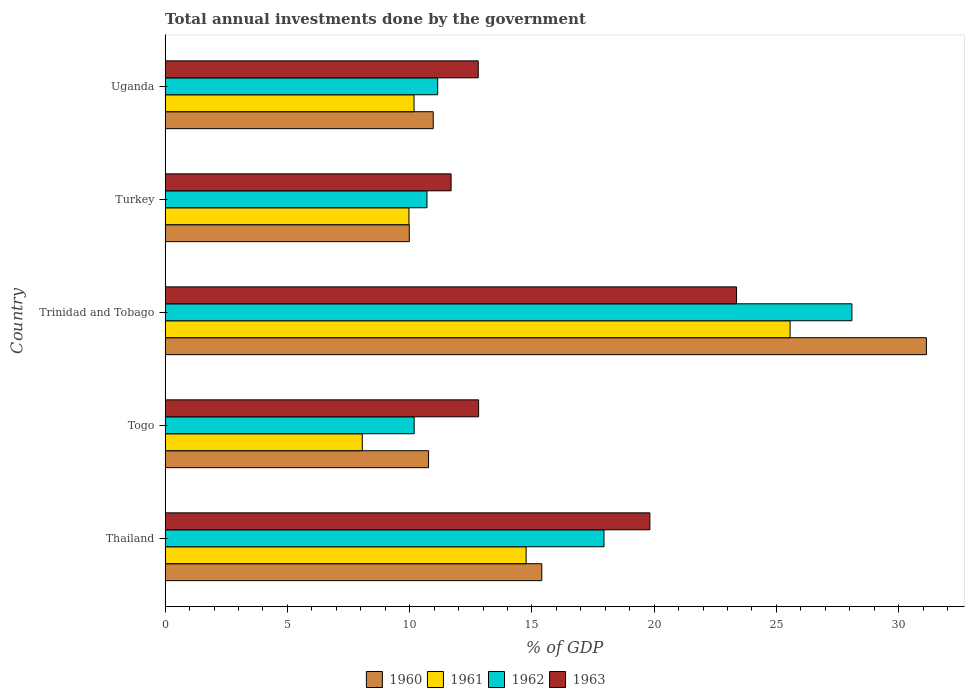How many different coloured bars are there?
Offer a terse response. 4. How many bars are there on the 2nd tick from the top?
Offer a terse response. 4. What is the label of the 2nd group of bars from the top?
Provide a short and direct response. Turkey. What is the total annual investments done by the government in 1962 in Togo?
Make the answer very short. 10.19. Across all countries, what is the maximum total annual investments done by the government in 1961?
Keep it short and to the point. 25.56. Across all countries, what is the minimum total annual investments done by the government in 1963?
Keep it short and to the point. 11.7. In which country was the total annual investments done by the government in 1960 maximum?
Your answer should be very brief. Trinidad and Tobago. In which country was the total annual investments done by the government in 1962 minimum?
Offer a very short reply. Togo. What is the total total annual investments done by the government in 1960 in the graph?
Your answer should be very brief. 78.26. What is the difference between the total annual investments done by the government in 1963 in Togo and that in Turkey?
Your answer should be compact. 1.13. What is the difference between the total annual investments done by the government in 1961 in Togo and the total annual investments done by the government in 1962 in Thailand?
Give a very brief answer. -9.88. What is the average total annual investments done by the government in 1963 per country?
Keep it short and to the point. 16.1. What is the difference between the total annual investments done by the government in 1962 and total annual investments done by the government in 1961 in Uganda?
Keep it short and to the point. 0.97. What is the ratio of the total annual investments done by the government in 1960 in Togo to that in Turkey?
Your answer should be very brief. 1.08. What is the difference between the highest and the second highest total annual investments done by the government in 1963?
Your answer should be very brief. 3.54. What is the difference between the highest and the lowest total annual investments done by the government in 1961?
Make the answer very short. 17.49. In how many countries, is the total annual investments done by the government in 1963 greater than the average total annual investments done by the government in 1963 taken over all countries?
Your response must be concise. 2. Is the sum of the total annual investments done by the government in 1963 in Thailand and Togo greater than the maximum total annual investments done by the government in 1961 across all countries?
Provide a succinct answer. Yes. Is it the case that in every country, the sum of the total annual investments done by the government in 1960 and total annual investments done by the government in 1961 is greater than the sum of total annual investments done by the government in 1963 and total annual investments done by the government in 1962?
Offer a very short reply. No. What does the 3rd bar from the top in Togo represents?
Make the answer very short. 1961. Is it the case that in every country, the sum of the total annual investments done by the government in 1961 and total annual investments done by the government in 1963 is greater than the total annual investments done by the government in 1960?
Give a very brief answer. Yes. How many bars are there?
Make the answer very short. 20. Are all the bars in the graph horizontal?
Offer a terse response. Yes. Does the graph contain any zero values?
Ensure brevity in your answer.  No. How many legend labels are there?
Offer a very short reply. 4. How are the legend labels stacked?
Your answer should be compact. Horizontal. What is the title of the graph?
Your answer should be very brief. Total annual investments done by the government. What is the label or title of the X-axis?
Give a very brief answer. % of GDP. What is the label or title of the Y-axis?
Your response must be concise. Country. What is the % of GDP in 1960 in Thailand?
Give a very brief answer. 15.41. What is the % of GDP of 1961 in Thailand?
Ensure brevity in your answer.  14.76. What is the % of GDP in 1962 in Thailand?
Your response must be concise. 17.95. What is the % of GDP in 1963 in Thailand?
Provide a short and direct response. 19.82. What is the % of GDP in 1960 in Togo?
Your answer should be compact. 10.77. What is the % of GDP in 1961 in Togo?
Offer a very short reply. 8.06. What is the % of GDP of 1962 in Togo?
Your answer should be very brief. 10.19. What is the % of GDP in 1963 in Togo?
Make the answer very short. 12.82. What is the % of GDP of 1960 in Trinidad and Tobago?
Keep it short and to the point. 31.13. What is the % of GDP of 1961 in Trinidad and Tobago?
Give a very brief answer. 25.56. What is the % of GDP in 1962 in Trinidad and Tobago?
Provide a succinct answer. 28.09. What is the % of GDP in 1963 in Trinidad and Tobago?
Offer a terse response. 23.37. What is the % of GDP of 1960 in Turkey?
Your answer should be compact. 9.99. What is the % of GDP in 1961 in Turkey?
Keep it short and to the point. 9.97. What is the % of GDP of 1962 in Turkey?
Provide a short and direct response. 10.71. What is the % of GDP in 1963 in Turkey?
Provide a succinct answer. 11.7. What is the % of GDP in 1960 in Uganda?
Give a very brief answer. 10.96. What is the % of GDP of 1961 in Uganda?
Your answer should be compact. 10.18. What is the % of GDP of 1962 in Uganda?
Provide a short and direct response. 11.15. What is the % of GDP of 1963 in Uganda?
Offer a very short reply. 12.81. Across all countries, what is the maximum % of GDP of 1960?
Provide a succinct answer. 31.13. Across all countries, what is the maximum % of GDP of 1961?
Provide a succinct answer. 25.56. Across all countries, what is the maximum % of GDP in 1962?
Provide a short and direct response. 28.09. Across all countries, what is the maximum % of GDP in 1963?
Provide a succinct answer. 23.37. Across all countries, what is the minimum % of GDP in 1960?
Ensure brevity in your answer.  9.99. Across all countries, what is the minimum % of GDP in 1961?
Offer a very short reply. 8.06. Across all countries, what is the minimum % of GDP in 1962?
Give a very brief answer. 10.19. Across all countries, what is the minimum % of GDP in 1963?
Offer a terse response. 11.7. What is the total % of GDP in 1960 in the graph?
Make the answer very short. 78.26. What is the total % of GDP in 1961 in the graph?
Keep it short and to the point. 68.54. What is the total % of GDP of 1962 in the graph?
Your answer should be very brief. 78.08. What is the total % of GDP in 1963 in the graph?
Give a very brief answer. 80.51. What is the difference between the % of GDP in 1960 in Thailand and that in Togo?
Make the answer very short. 4.63. What is the difference between the % of GDP of 1961 in Thailand and that in Togo?
Your answer should be compact. 6.7. What is the difference between the % of GDP of 1962 in Thailand and that in Togo?
Provide a succinct answer. 7.76. What is the difference between the % of GDP in 1963 in Thailand and that in Togo?
Ensure brevity in your answer.  7. What is the difference between the % of GDP of 1960 in Thailand and that in Trinidad and Tobago?
Offer a very short reply. -15.73. What is the difference between the % of GDP of 1961 in Thailand and that in Trinidad and Tobago?
Your answer should be compact. -10.79. What is the difference between the % of GDP of 1962 in Thailand and that in Trinidad and Tobago?
Provide a short and direct response. -10.14. What is the difference between the % of GDP in 1963 in Thailand and that in Trinidad and Tobago?
Your answer should be compact. -3.54. What is the difference between the % of GDP in 1960 in Thailand and that in Turkey?
Your response must be concise. 5.42. What is the difference between the % of GDP of 1961 in Thailand and that in Turkey?
Give a very brief answer. 4.79. What is the difference between the % of GDP in 1962 in Thailand and that in Turkey?
Keep it short and to the point. 7.24. What is the difference between the % of GDP of 1963 in Thailand and that in Turkey?
Make the answer very short. 8.13. What is the difference between the % of GDP of 1960 in Thailand and that in Uganda?
Keep it short and to the point. 4.44. What is the difference between the % of GDP in 1961 in Thailand and that in Uganda?
Ensure brevity in your answer.  4.58. What is the difference between the % of GDP of 1962 in Thailand and that in Uganda?
Keep it short and to the point. 6.8. What is the difference between the % of GDP of 1963 in Thailand and that in Uganda?
Offer a terse response. 7.02. What is the difference between the % of GDP of 1960 in Togo and that in Trinidad and Tobago?
Give a very brief answer. -20.36. What is the difference between the % of GDP in 1961 in Togo and that in Trinidad and Tobago?
Provide a succinct answer. -17.49. What is the difference between the % of GDP in 1962 in Togo and that in Trinidad and Tobago?
Your answer should be very brief. -17.9. What is the difference between the % of GDP of 1963 in Togo and that in Trinidad and Tobago?
Offer a terse response. -10.55. What is the difference between the % of GDP of 1960 in Togo and that in Turkey?
Offer a very short reply. 0.79. What is the difference between the % of GDP of 1961 in Togo and that in Turkey?
Offer a terse response. -1.91. What is the difference between the % of GDP of 1962 in Togo and that in Turkey?
Offer a terse response. -0.52. What is the difference between the % of GDP of 1963 in Togo and that in Turkey?
Give a very brief answer. 1.13. What is the difference between the % of GDP of 1960 in Togo and that in Uganda?
Keep it short and to the point. -0.19. What is the difference between the % of GDP of 1961 in Togo and that in Uganda?
Provide a succinct answer. -2.12. What is the difference between the % of GDP of 1962 in Togo and that in Uganda?
Keep it short and to the point. -0.96. What is the difference between the % of GDP in 1963 in Togo and that in Uganda?
Keep it short and to the point. 0.01. What is the difference between the % of GDP in 1960 in Trinidad and Tobago and that in Turkey?
Keep it short and to the point. 21.15. What is the difference between the % of GDP of 1961 in Trinidad and Tobago and that in Turkey?
Provide a short and direct response. 15.59. What is the difference between the % of GDP in 1962 in Trinidad and Tobago and that in Turkey?
Your answer should be compact. 17.38. What is the difference between the % of GDP of 1963 in Trinidad and Tobago and that in Turkey?
Offer a terse response. 11.67. What is the difference between the % of GDP in 1960 in Trinidad and Tobago and that in Uganda?
Make the answer very short. 20.17. What is the difference between the % of GDP in 1961 in Trinidad and Tobago and that in Uganda?
Ensure brevity in your answer.  15.38. What is the difference between the % of GDP in 1962 in Trinidad and Tobago and that in Uganda?
Keep it short and to the point. 16.94. What is the difference between the % of GDP in 1963 in Trinidad and Tobago and that in Uganda?
Your answer should be compact. 10.56. What is the difference between the % of GDP of 1960 in Turkey and that in Uganda?
Ensure brevity in your answer.  -0.98. What is the difference between the % of GDP of 1961 in Turkey and that in Uganda?
Ensure brevity in your answer.  -0.21. What is the difference between the % of GDP in 1962 in Turkey and that in Uganda?
Keep it short and to the point. -0.44. What is the difference between the % of GDP in 1963 in Turkey and that in Uganda?
Provide a short and direct response. -1.11. What is the difference between the % of GDP of 1960 in Thailand and the % of GDP of 1961 in Togo?
Keep it short and to the point. 7.34. What is the difference between the % of GDP of 1960 in Thailand and the % of GDP of 1962 in Togo?
Your response must be concise. 5.22. What is the difference between the % of GDP in 1960 in Thailand and the % of GDP in 1963 in Togo?
Keep it short and to the point. 2.58. What is the difference between the % of GDP of 1961 in Thailand and the % of GDP of 1962 in Togo?
Make the answer very short. 4.58. What is the difference between the % of GDP of 1961 in Thailand and the % of GDP of 1963 in Togo?
Give a very brief answer. 1.94. What is the difference between the % of GDP of 1962 in Thailand and the % of GDP of 1963 in Togo?
Give a very brief answer. 5.13. What is the difference between the % of GDP in 1960 in Thailand and the % of GDP in 1961 in Trinidad and Tobago?
Make the answer very short. -10.15. What is the difference between the % of GDP of 1960 in Thailand and the % of GDP of 1962 in Trinidad and Tobago?
Your response must be concise. -12.68. What is the difference between the % of GDP in 1960 in Thailand and the % of GDP in 1963 in Trinidad and Tobago?
Offer a very short reply. -7.96. What is the difference between the % of GDP of 1961 in Thailand and the % of GDP of 1962 in Trinidad and Tobago?
Keep it short and to the point. -13.32. What is the difference between the % of GDP of 1961 in Thailand and the % of GDP of 1963 in Trinidad and Tobago?
Give a very brief answer. -8.6. What is the difference between the % of GDP in 1962 in Thailand and the % of GDP in 1963 in Trinidad and Tobago?
Make the answer very short. -5.42. What is the difference between the % of GDP of 1960 in Thailand and the % of GDP of 1961 in Turkey?
Offer a very short reply. 5.43. What is the difference between the % of GDP in 1960 in Thailand and the % of GDP in 1962 in Turkey?
Your answer should be compact. 4.7. What is the difference between the % of GDP of 1960 in Thailand and the % of GDP of 1963 in Turkey?
Ensure brevity in your answer.  3.71. What is the difference between the % of GDP in 1961 in Thailand and the % of GDP in 1962 in Turkey?
Make the answer very short. 4.05. What is the difference between the % of GDP in 1961 in Thailand and the % of GDP in 1963 in Turkey?
Make the answer very short. 3.07. What is the difference between the % of GDP of 1962 in Thailand and the % of GDP of 1963 in Turkey?
Make the answer very short. 6.25. What is the difference between the % of GDP of 1960 in Thailand and the % of GDP of 1961 in Uganda?
Offer a terse response. 5.23. What is the difference between the % of GDP in 1960 in Thailand and the % of GDP in 1962 in Uganda?
Offer a very short reply. 4.26. What is the difference between the % of GDP of 1960 in Thailand and the % of GDP of 1963 in Uganda?
Offer a very short reply. 2.6. What is the difference between the % of GDP in 1961 in Thailand and the % of GDP in 1962 in Uganda?
Provide a short and direct response. 3.62. What is the difference between the % of GDP of 1961 in Thailand and the % of GDP of 1963 in Uganda?
Make the answer very short. 1.96. What is the difference between the % of GDP of 1962 in Thailand and the % of GDP of 1963 in Uganda?
Your response must be concise. 5.14. What is the difference between the % of GDP of 1960 in Togo and the % of GDP of 1961 in Trinidad and Tobago?
Provide a short and direct response. -14.78. What is the difference between the % of GDP of 1960 in Togo and the % of GDP of 1962 in Trinidad and Tobago?
Offer a very short reply. -17.31. What is the difference between the % of GDP in 1960 in Togo and the % of GDP in 1963 in Trinidad and Tobago?
Ensure brevity in your answer.  -12.59. What is the difference between the % of GDP in 1961 in Togo and the % of GDP in 1962 in Trinidad and Tobago?
Give a very brief answer. -20.02. What is the difference between the % of GDP in 1961 in Togo and the % of GDP in 1963 in Trinidad and Tobago?
Keep it short and to the point. -15.3. What is the difference between the % of GDP in 1962 in Togo and the % of GDP in 1963 in Trinidad and Tobago?
Make the answer very short. -13.18. What is the difference between the % of GDP in 1960 in Togo and the % of GDP in 1961 in Turkey?
Make the answer very short. 0.8. What is the difference between the % of GDP in 1960 in Togo and the % of GDP in 1962 in Turkey?
Make the answer very short. 0.06. What is the difference between the % of GDP of 1960 in Togo and the % of GDP of 1963 in Turkey?
Provide a succinct answer. -0.92. What is the difference between the % of GDP of 1961 in Togo and the % of GDP of 1962 in Turkey?
Offer a terse response. -2.65. What is the difference between the % of GDP in 1961 in Togo and the % of GDP in 1963 in Turkey?
Ensure brevity in your answer.  -3.63. What is the difference between the % of GDP in 1962 in Togo and the % of GDP in 1963 in Turkey?
Your response must be concise. -1.51. What is the difference between the % of GDP of 1960 in Togo and the % of GDP of 1961 in Uganda?
Your response must be concise. 0.59. What is the difference between the % of GDP in 1960 in Togo and the % of GDP in 1962 in Uganda?
Give a very brief answer. -0.37. What is the difference between the % of GDP of 1960 in Togo and the % of GDP of 1963 in Uganda?
Offer a terse response. -2.03. What is the difference between the % of GDP of 1961 in Togo and the % of GDP of 1962 in Uganda?
Offer a terse response. -3.08. What is the difference between the % of GDP in 1961 in Togo and the % of GDP in 1963 in Uganda?
Make the answer very short. -4.74. What is the difference between the % of GDP in 1962 in Togo and the % of GDP in 1963 in Uganda?
Offer a very short reply. -2.62. What is the difference between the % of GDP of 1960 in Trinidad and Tobago and the % of GDP of 1961 in Turkey?
Make the answer very short. 21.16. What is the difference between the % of GDP of 1960 in Trinidad and Tobago and the % of GDP of 1962 in Turkey?
Offer a terse response. 20.42. What is the difference between the % of GDP in 1960 in Trinidad and Tobago and the % of GDP in 1963 in Turkey?
Offer a terse response. 19.44. What is the difference between the % of GDP of 1961 in Trinidad and Tobago and the % of GDP of 1962 in Turkey?
Provide a short and direct response. 14.85. What is the difference between the % of GDP of 1961 in Trinidad and Tobago and the % of GDP of 1963 in Turkey?
Your answer should be compact. 13.86. What is the difference between the % of GDP of 1962 in Trinidad and Tobago and the % of GDP of 1963 in Turkey?
Your response must be concise. 16.39. What is the difference between the % of GDP of 1960 in Trinidad and Tobago and the % of GDP of 1961 in Uganda?
Keep it short and to the point. 20.95. What is the difference between the % of GDP in 1960 in Trinidad and Tobago and the % of GDP in 1962 in Uganda?
Ensure brevity in your answer.  19.99. What is the difference between the % of GDP of 1960 in Trinidad and Tobago and the % of GDP of 1963 in Uganda?
Your answer should be very brief. 18.33. What is the difference between the % of GDP of 1961 in Trinidad and Tobago and the % of GDP of 1962 in Uganda?
Your response must be concise. 14.41. What is the difference between the % of GDP of 1961 in Trinidad and Tobago and the % of GDP of 1963 in Uganda?
Provide a succinct answer. 12.75. What is the difference between the % of GDP in 1962 in Trinidad and Tobago and the % of GDP in 1963 in Uganda?
Give a very brief answer. 15.28. What is the difference between the % of GDP in 1960 in Turkey and the % of GDP in 1961 in Uganda?
Make the answer very short. -0.2. What is the difference between the % of GDP in 1960 in Turkey and the % of GDP in 1962 in Uganda?
Keep it short and to the point. -1.16. What is the difference between the % of GDP of 1960 in Turkey and the % of GDP of 1963 in Uganda?
Offer a very short reply. -2.82. What is the difference between the % of GDP of 1961 in Turkey and the % of GDP of 1962 in Uganda?
Provide a succinct answer. -1.18. What is the difference between the % of GDP in 1961 in Turkey and the % of GDP in 1963 in Uganda?
Your answer should be very brief. -2.83. What is the difference between the % of GDP in 1962 in Turkey and the % of GDP in 1963 in Uganda?
Keep it short and to the point. -2.1. What is the average % of GDP in 1960 per country?
Provide a succinct answer. 15.65. What is the average % of GDP in 1961 per country?
Provide a short and direct response. 13.71. What is the average % of GDP in 1962 per country?
Offer a terse response. 15.62. What is the average % of GDP of 1963 per country?
Your response must be concise. 16.1. What is the difference between the % of GDP of 1960 and % of GDP of 1961 in Thailand?
Provide a succinct answer. 0.64. What is the difference between the % of GDP in 1960 and % of GDP in 1962 in Thailand?
Give a very brief answer. -2.54. What is the difference between the % of GDP in 1960 and % of GDP in 1963 in Thailand?
Provide a short and direct response. -4.42. What is the difference between the % of GDP of 1961 and % of GDP of 1962 in Thailand?
Give a very brief answer. -3.18. What is the difference between the % of GDP in 1961 and % of GDP in 1963 in Thailand?
Provide a short and direct response. -5.06. What is the difference between the % of GDP in 1962 and % of GDP in 1963 in Thailand?
Your answer should be compact. -1.88. What is the difference between the % of GDP in 1960 and % of GDP in 1961 in Togo?
Give a very brief answer. 2.71. What is the difference between the % of GDP in 1960 and % of GDP in 1962 in Togo?
Your answer should be compact. 0.59. What is the difference between the % of GDP of 1960 and % of GDP of 1963 in Togo?
Provide a succinct answer. -2.05. What is the difference between the % of GDP in 1961 and % of GDP in 1962 in Togo?
Your answer should be compact. -2.12. What is the difference between the % of GDP of 1961 and % of GDP of 1963 in Togo?
Offer a terse response. -4.76. What is the difference between the % of GDP in 1962 and % of GDP in 1963 in Togo?
Your response must be concise. -2.64. What is the difference between the % of GDP in 1960 and % of GDP in 1961 in Trinidad and Tobago?
Keep it short and to the point. 5.58. What is the difference between the % of GDP of 1960 and % of GDP of 1962 in Trinidad and Tobago?
Give a very brief answer. 3.05. What is the difference between the % of GDP of 1960 and % of GDP of 1963 in Trinidad and Tobago?
Your answer should be very brief. 7.77. What is the difference between the % of GDP of 1961 and % of GDP of 1962 in Trinidad and Tobago?
Your response must be concise. -2.53. What is the difference between the % of GDP of 1961 and % of GDP of 1963 in Trinidad and Tobago?
Your answer should be very brief. 2.19. What is the difference between the % of GDP of 1962 and % of GDP of 1963 in Trinidad and Tobago?
Provide a succinct answer. 4.72. What is the difference between the % of GDP in 1960 and % of GDP in 1961 in Turkey?
Offer a terse response. 0.01. What is the difference between the % of GDP of 1960 and % of GDP of 1962 in Turkey?
Make the answer very short. -0.72. What is the difference between the % of GDP in 1960 and % of GDP in 1963 in Turkey?
Your answer should be compact. -1.71. What is the difference between the % of GDP in 1961 and % of GDP in 1962 in Turkey?
Offer a terse response. -0.74. What is the difference between the % of GDP of 1961 and % of GDP of 1963 in Turkey?
Provide a short and direct response. -1.72. What is the difference between the % of GDP of 1962 and % of GDP of 1963 in Turkey?
Your response must be concise. -0.99. What is the difference between the % of GDP of 1960 and % of GDP of 1961 in Uganda?
Offer a terse response. 0.78. What is the difference between the % of GDP of 1960 and % of GDP of 1962 in Uganda?
Provide a succinct answer. -0.18. What is the difference between the % of GDP of 1960 and % of GDP of 1963 in Uganda?
Give a very brief answer. -1.84. What is the difference between the % of GDP in 1961 and % of GDP in 1962 in Uganda?
Your answer should be very brief. -0.97. What is the difference between the % of GDP in 1961 and % of GDP in 1963 in Uganda?
Provide a short and direct response. -2.63. What is the difference between the % of GDP in 1962 and % of GDP in 1963 in Uganda?
Your response must be concise. -1.66. What is the ratio of the % of GDP in 1960 in Thailand to that in Togo?
Ensure brevity in your answer.  1.43. What is the ratio of the % of GDP in 1961 in Thailand to that in Togo?
Provide a short and direct response. 1.83. What is the ratio of the % of GDP of 1962 in Thailand to that in Togo?
Your answer should be very brief. 1.76. What is the ratio of the % of GDP of 1963 in Thailand to that in Togo?
Your response must be concise. 1.55. What is the ratio of the % of GDP of 1960 in Thailand to that in Trinidad and Tobago?
Ensure brevity in your answer.  0.49. What is the ratio of the % of GDP in 1961 in Thailand to that in Trinidad and Tobago?
Make the answer very short. 0.58. What is the ratio of the % of GDP in 1962 in Thailand to that in Trinidad and Tobago?
Your response must be concise. 0.64. What is the ratio of the % of GDP in 1963 in Thailand to that in Trinidad and Tobago?
Give a very brief answer. 0.85. What is the ratio of the % of GDP in 1960 in Thailand to that in Turkey?
Your answer should be compact. 1.54. What is the ratio of the % of GDP of 1961 in Thailand to that in Turkey?
Give a very brief answer. 1.48. What is the ratio of the % of GDP in 1962 in Thailand to that in Turkey?
Provide a succinct answer. 1.68. What is the ratio of the % of GDP in 1963 in Thailand to that in Turkey?
Ensure brevity in your answer.  1.7. What is the ratio of the % of GDP in 1960 in Thailand to that in Uganda?
Offer a very short reply. 1.41. What is the ratio of the % of GDP of 1961 in Thailand to that in Uganda?
Make the answer very short. 1.45. What is the ratio of the % of GDP of 1962 in Thailand to that in Uganda?
Your answer should be compact. 1.61. What is the ratio of the % of GDP of 1963 in Thailand to that in Uganda?
Keep it short and to the point. 1.55. What is the ratio of the % of GDP of 1960 in Togo to that in Trinidad and Tobago?
Keep it short and to the point. 0.35. What is the ratio of the % of GDP in 1961 in Togo to that in Trinidad and Tobago?
Your response must be concise. 0.32. What is the ratio of the % of GDP of 1962 in Togo to that in Trinidad and Tobago?
Ensure brevity in your answer.  0.36. What is the ratio of the % of GDP of 1963 in Togo to that in Trinidad and Tobago?
Provide a succinct answer. 0.55. What is the ratio of the % of GDP of 1960 in Togo to that in Turkey?
Give a very brief answer. 1.08. What is the ratio of the % of GDP in 1961 in Togo to that in Turkey?
Your answer should be very brief. 0.81. What is the ratio of the % of GDP of 1962 in Togo to that in Turkey?
Offer a very short reply. 0.95. What is the ratio of the % of GDP in 1963 in Togo to that in Turkey?
Give a very brief answer. 1.1. What is the ratio of the % of GDP in 1960 in Togo to that in Uganda?
Your response must be concise. 0.98. What is the ratio of the % of GDP of 1961 in Togo to that in Uganda?
Make the answer very short. 0.79. What is the ratio of the % of GDP of 1962 in Togo to that in Uganda?
Ensure brevity in your answer.  0.91. What is the ratio of the % of GDP in 1963 in Togo to that in Uganda?
Your answer should be very brief. 1. What is the ratio of the % of GDP in 1960 in Trinidad and Tobago to that in Turkey?
Offer a very short reply. 3.12. What is the ratio of the % of GDP in 1961 in Trinidad and Tobago to that in Turkey?
Offer a terse response. 2.56. What is the ratio of the % of GDP in 1962 in Trinidad and Tobago to that in Turkey?
Make the answer very short. 2.62. What is the ratio of the % of GDP in 1963 in Trinidad and Tobago to that in Turkey?
Keep it short and to the point. 2. What is the ratio of the % of GDP in 1960 in Trinidad and Tobago to that in Uganda?
Give a very brief answer. 2.84. What is the ratio of the % of GDP of 1961 in Trinidad and Tobago to that in Uganda?
Your answer should be compact. 2.51. What is the ratio of the % of GDP in 1962 in Trinidad and Tobago to that in Uganda?
Your response must be concise. 2.52. What is the ratio of the % of GDP of 1963 in Trinidad and Tobago to that in Uganda?
Your answer should be very brief. 1.82. What is the ratio of the % of GDP in 1960 in Turkey to that in Uganda?
Give a very brief answer. 0.91. What is the ratio of the % of GDP of 1961 in Turkey to that in Uganda?
Provide a short and direct response. 0.98. What is the ratio of the % of GDP of 1962 in Turkey to that in Uganda?
Your answer should be very brief. 0.96. What is the ratio of the % of GDP in 1963 in Turkey to that in Uganda?
Your answer should be compact. 0.91. What is the difference between the highest and the second highest % of GDP in 1960?
Offer a terse response. 15.73. What is the difference between the highest and the second highest % of GDP of 1961?
Your answer should be very brief. 10.79. What is the difference between the highest and the second highest % of GDP of 1962?
Your answer should be compact. 10.14. What is the difference between the highest and the second highest % of GDP of 1963?
Give a very brief answer. 3.54. What is the difference between the highest and the lowest % of GDP in 1960?
Offer a very short reply. 21.15. What is the difference between the highest and the lowest % of GDP of 1961?
Provide a succinct answer. 17.49. What is the difference between the highest and the lowest % of GDP in 1962?
Ensure brevity in your answer.  17.9. What is the difference between the highest and the lowest % of GDP of 1963?
Your answer should be very brief. 11.67. 